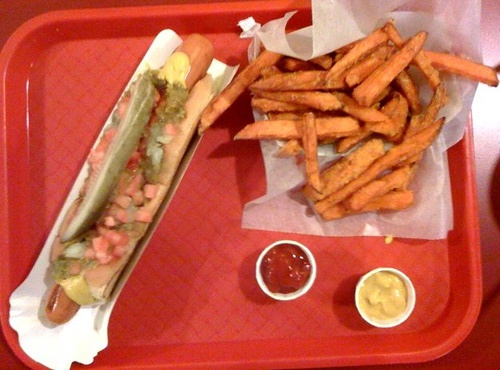Describe the objects in this image and their specific colors. I can see dining table in brown, red, lightpink, and tan tones, hot dog in brown and tan tones, carrot in brown, red, salmon, and maroon tones, carrot in brown, red, orange, and maroon tones, and carrot in brown, orange, and red tones in this image. 